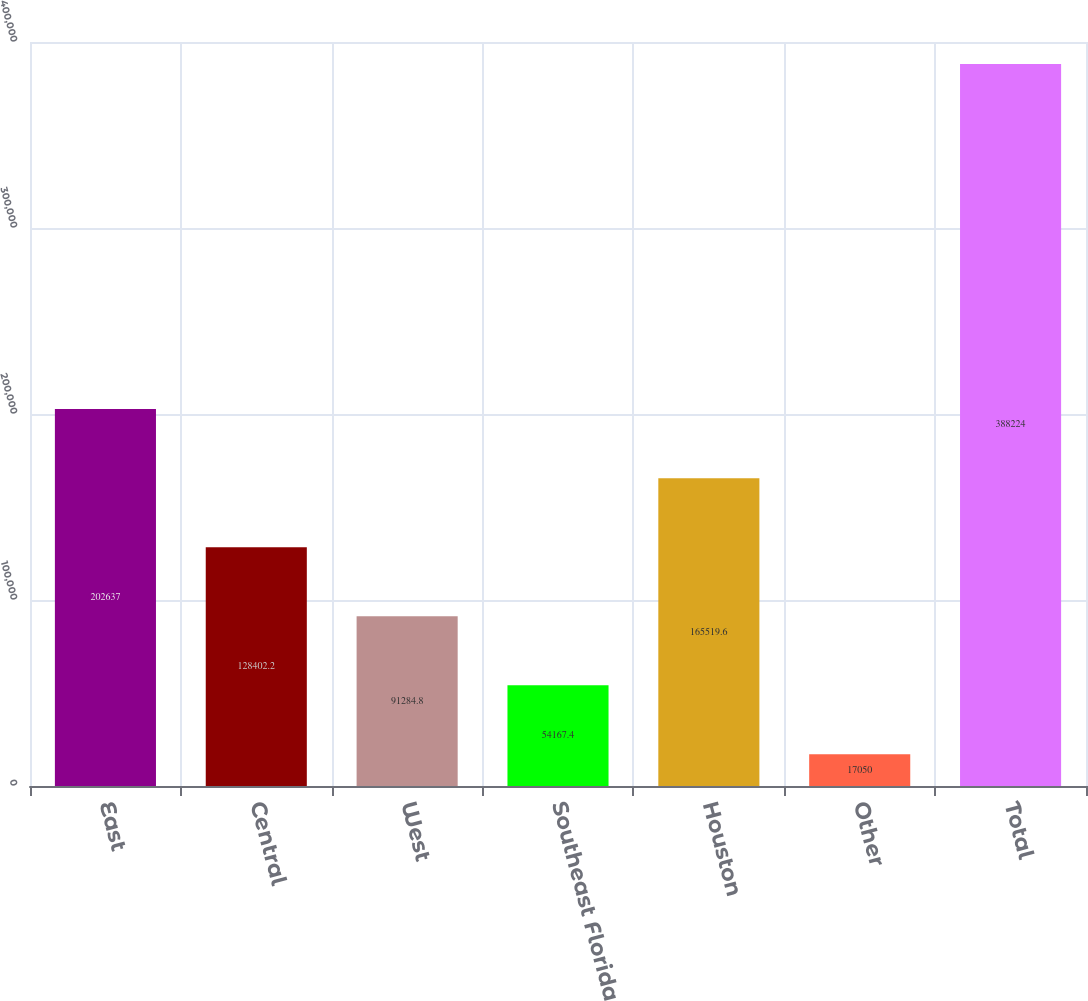<chart> <loc_0><loc_0><loc_500><loc_500><bar_chart><fcel>East<fcel>Central<fcel>West<fcel>Southeast Florida<fcel>Houston<fcel>Other<fcel>Total<nl><fcel>202637<fcel>128402<fcel>91284.8<fcel>54167.4<fcel>165520<fcel>17050<fcel>388224<nl></chart> 